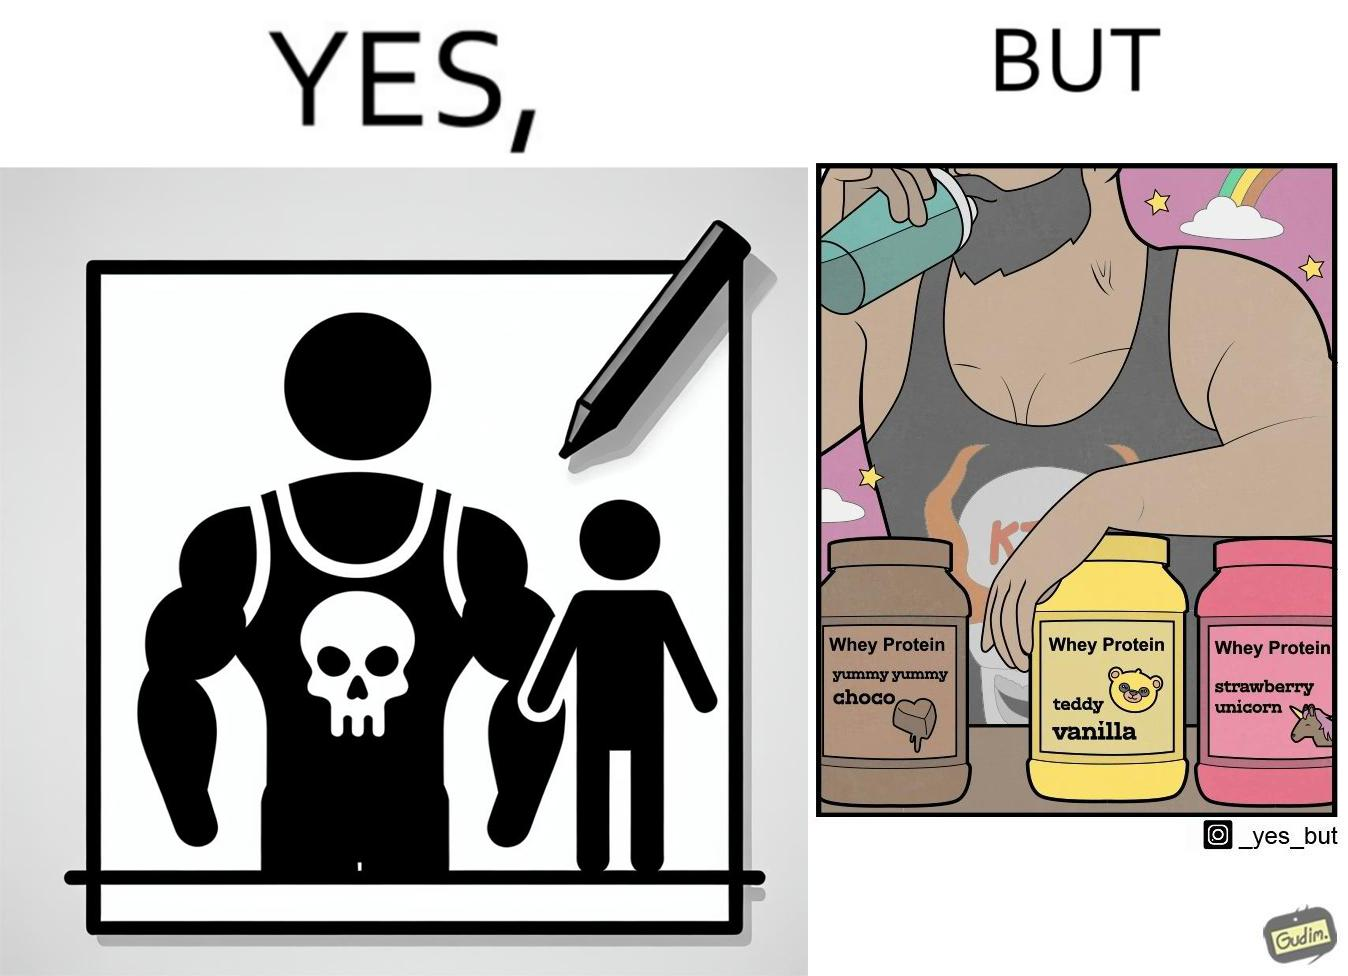Compare the left and right sides of this image. In the left part of the image: a well-built person wearing a tank top with the word "KILL" on an image of a skull. In the right part of the image: a well-built person consuming whey protein from one of three flavours. 